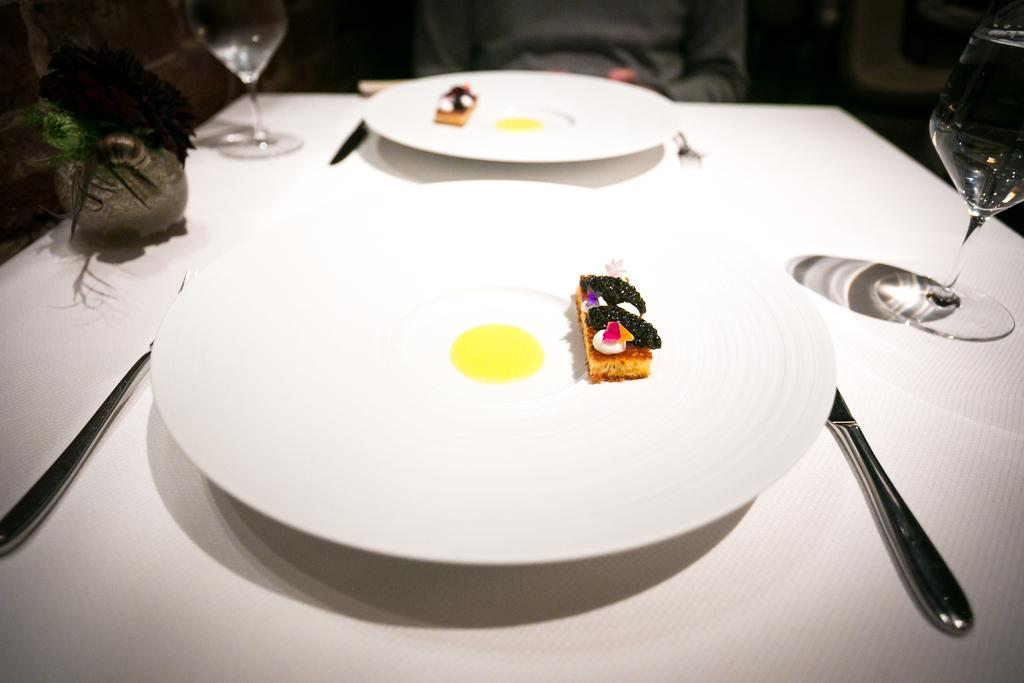What piece of furniture is present in the image? There is a table in the image. What is placed on the table? There is a plate, a glass, a knife, and a fork on the table. What is on the plate? There is food on the plate. What type of bell can be heard ringing in the image? There is no bell present in the image, and therefore no sound can be heard. 